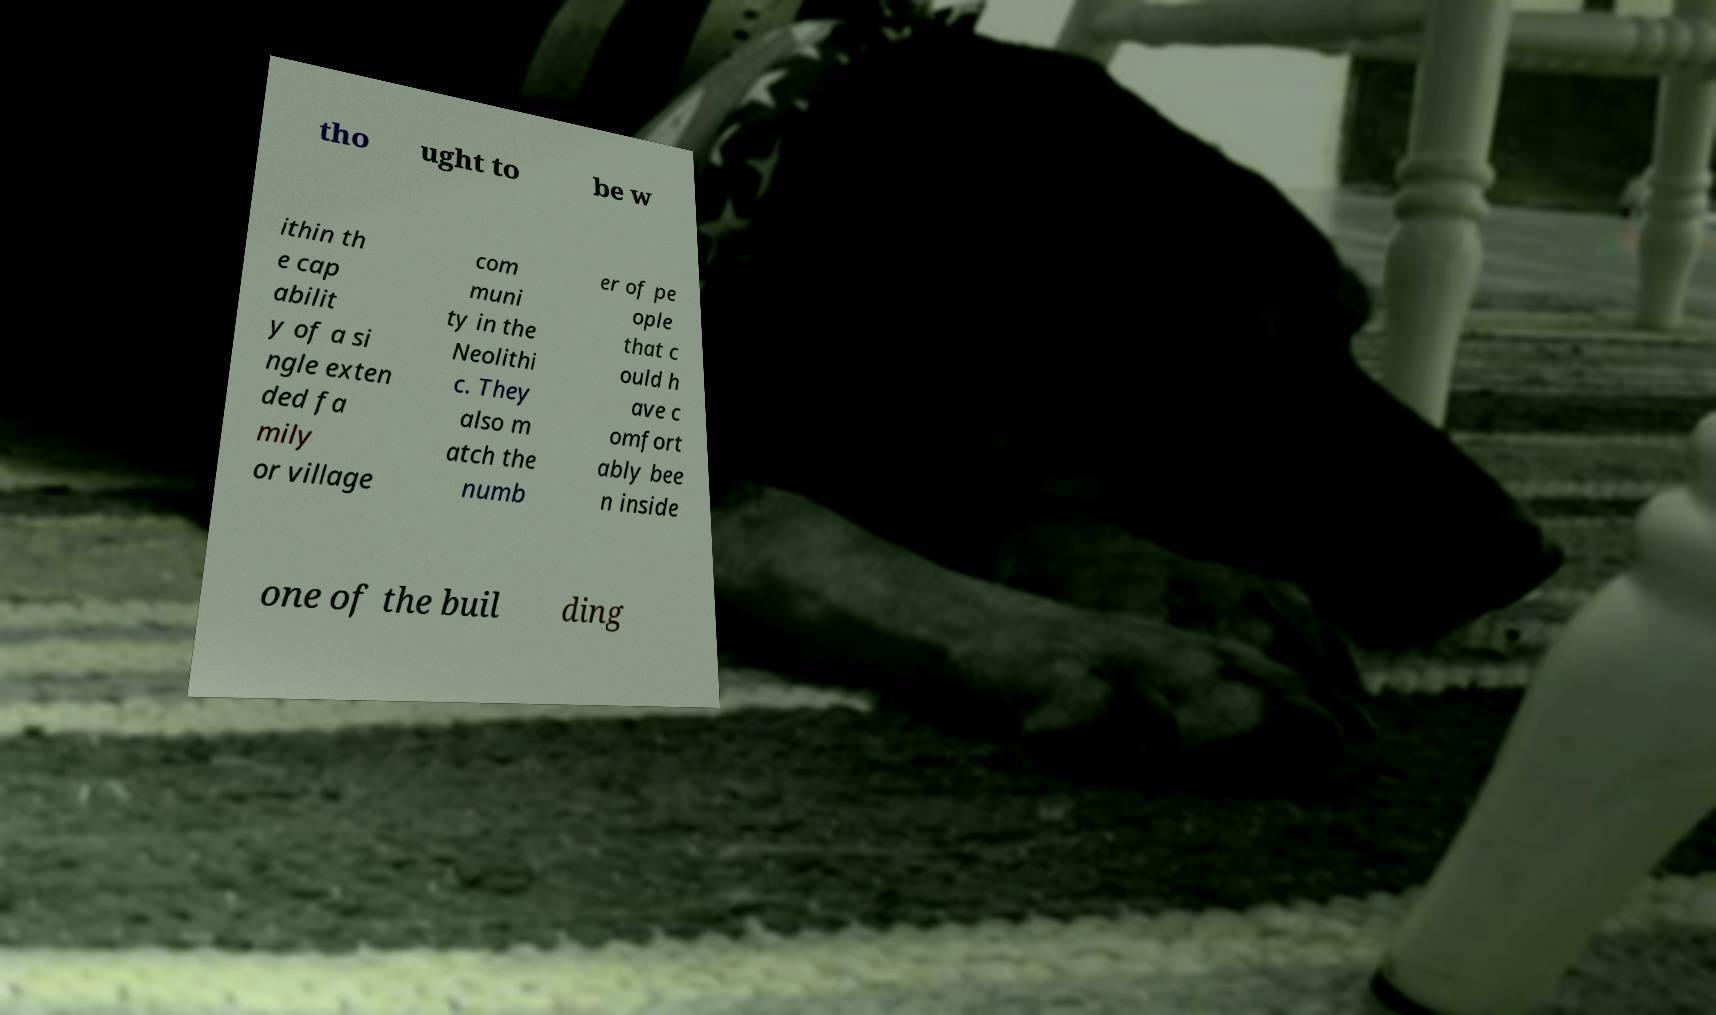Can you read and provide the text displayed in the image?This photo seems to have some interesting text. Can you extract and type it out for me? tho ught to be w ithin th e cap abilit y of a si ngle exten ded fa mily or village com muni ty in the Neolithi c. They also m atch the numb er of pe ople that c ould h ave c omfort ably bee n inside one of the buil ding 